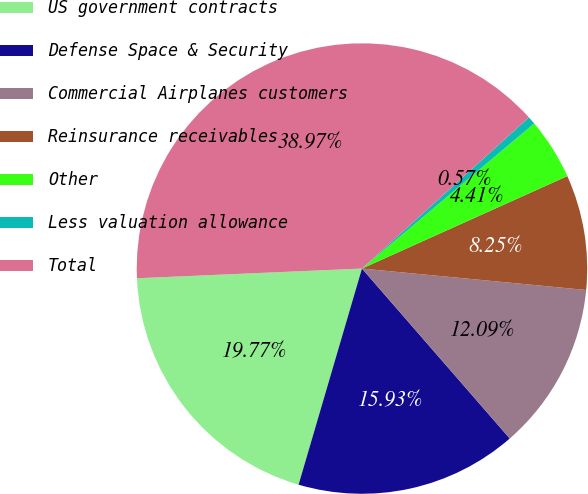<chart> <loc_0><loc_0><loc_500><loc_500><pie_chart><fcel>US government contracts<fcel>Defense Space & Security<fcel>Commercial Airplanes customers<fcel>Reinsurance receivables<fcel>Other<fcel>Less valuation allowance<fcel>Total<nl><fcel>19.77%<fcel>15.93%<fcel>12.09%<fcel>8.25%<fcel>4.41%<fcel>0.57%<fcel>38.97%<nl></chart> 